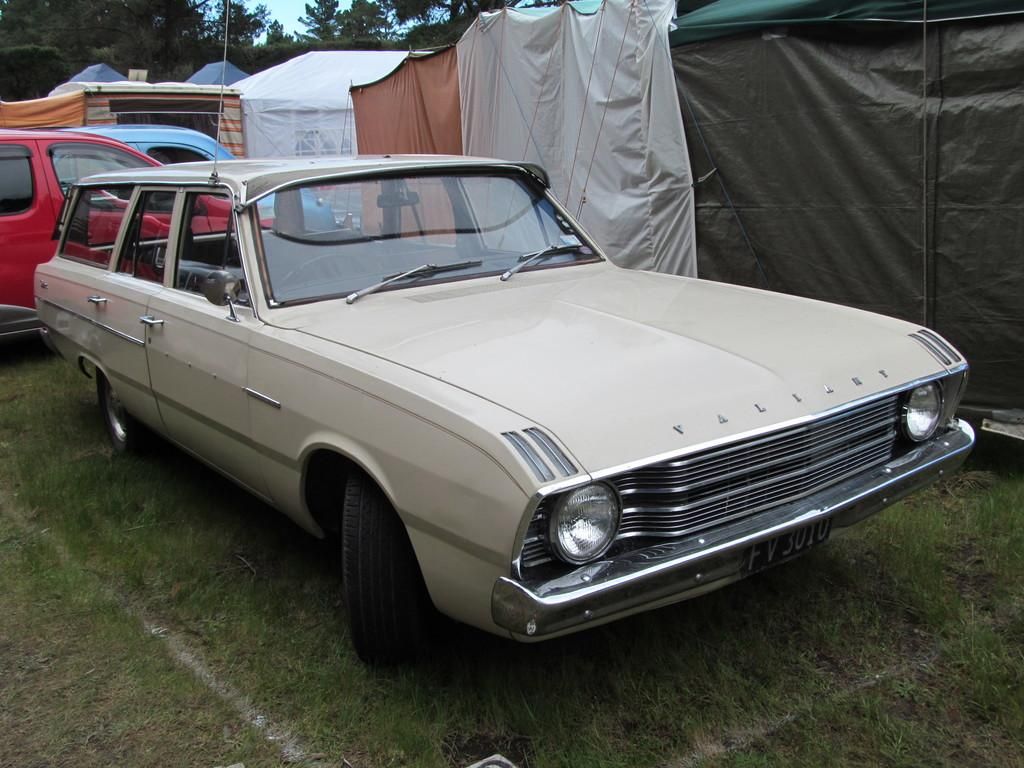How many cars are parked on the grass in the image? There are three cars parked on the grass in the image. What other structures are near the grass? There are tents beside the grass in the image. What can be seen in the background of the image? There are trees and the sky visible in the background of the image. What type of frogs can be seen hopping on the feet of the people in the image? There are no frogs or people present in the image, so this scenario cannot be observed. 